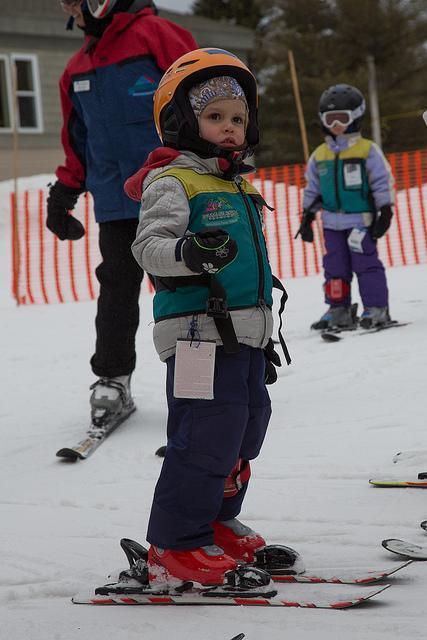How many little kids have skis on?
Give a very brief answer. 2. How many people are there?
Give a very brief answer. 3. How many knives are in the knife block?
Give a very brief answer. 0. 